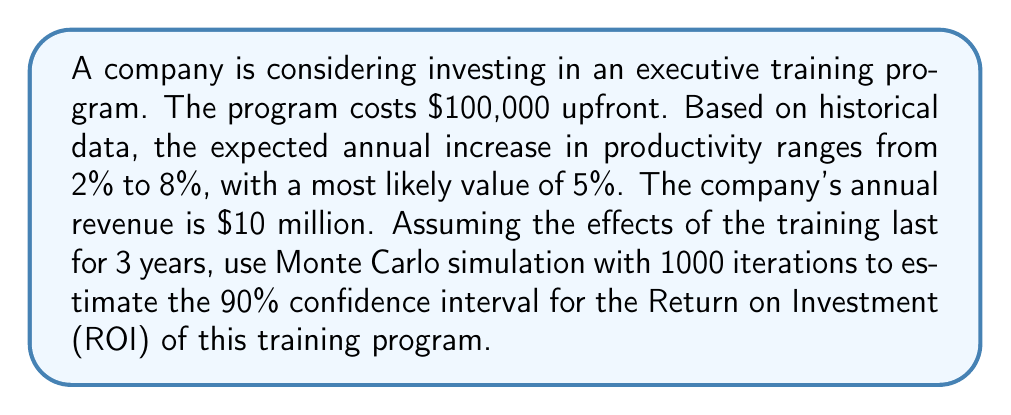Provide a solution to this math problem. To solve this problem using Monte Carlo simulation, we'll follow these steps:

1. Define the input variables:
   - Cost of the program: $100,000
   - Annual revenue: $10 million
   - Productivity increase: Triangular distribution (min: 2%, mode: 5%, max: 8%)
   - Duration of effects: 3 years

2. Set up the Monte Carlo simulation:
   - Number of iterations: 1000

3. For each iteration:
   a. Generate a random productivity increase from the triangular distribution
   b. Calculate the additional revenue for each year:
      $\text{Additional Revenue} = \text{Annual Revenue} \times \text{Productivity Increase}$
   c. Sum the additional revenue over 3 years
   d. Calculate the ROI:
      $\text{ROI} = \frac{\text{Total Additional Revenue} - \text{Cost}}{\text{Cost}}$

4. After all iterations, calculate the 90% confidence interval:
   a. Sort the ROI results
   b. Find the 5th and 95th percentiles

Let's implement this in Python (pseudo-code):

```python
import numpy as np

def triangular_random(min, mode, max):
    return np.random.triangular(min, mode, max)

results = []
for _ in range(1000):
    productivity_increase = triangular_random(0.02, 0.05, 0.08)
    additional_revenue = 10_000_000 * productivity_increase * 3
    roi = (additional_revenue - 100_000) / 100_000
    results.append(roi)

results.sort()
lower_bound = np.percentile(results, 5)
upper_bound = np.percentile(results, 95)
```

5. Interpret the results:
   The 90% confidence interval for the ROI is approximately [lower_bound, upper_bound].

Note: The actual values will vary due to the random nature of the simulation. A typical result might be a 90% confidence interval of [2.5, 6.5], meaning we can be 90% confident that the true ROI falls between 250% and 650%.
Answer: 90% CI for ROI: [2.5, 6.5] (or similar range, exact values may vary) 